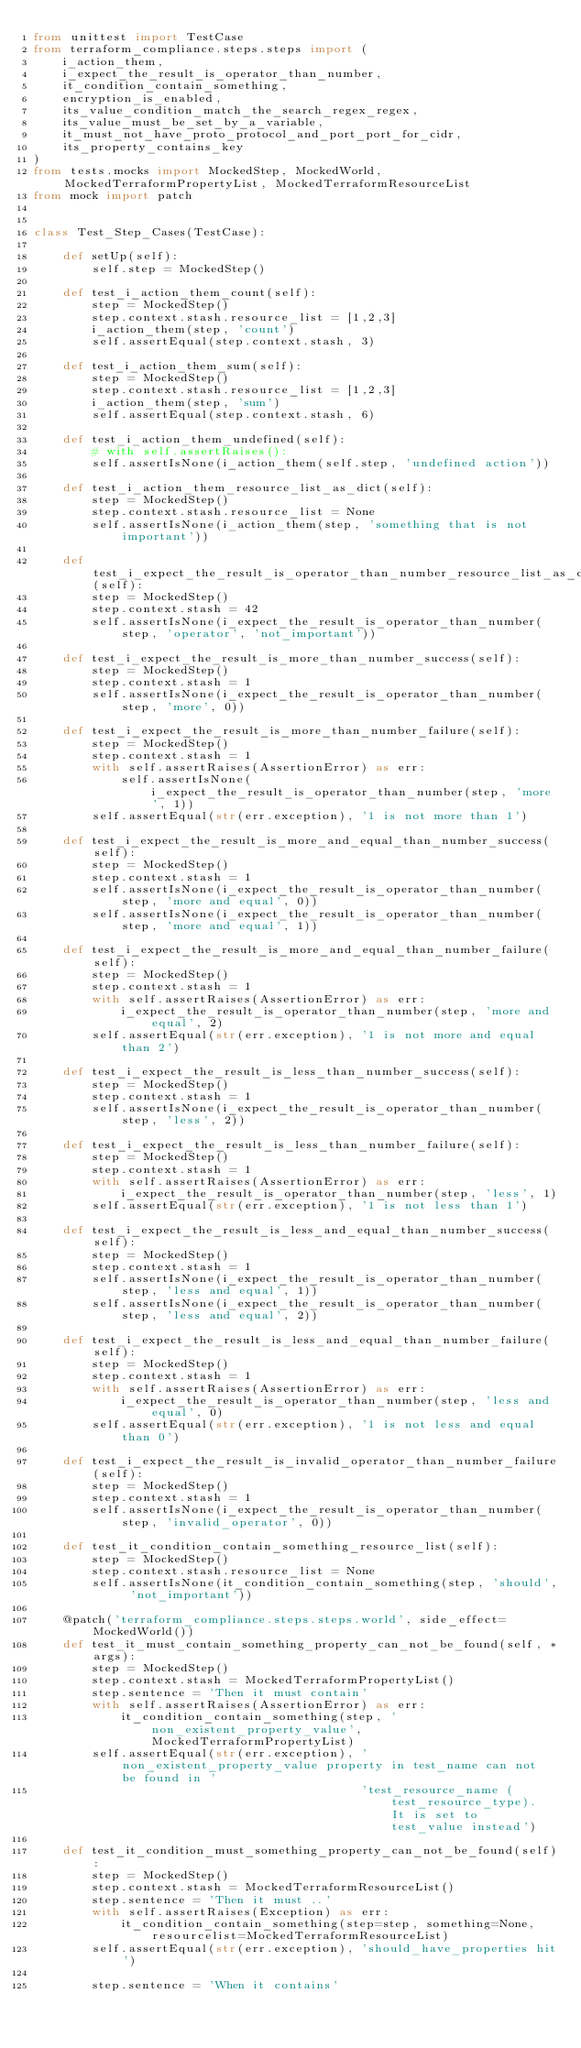Convert code to text. <code><loc_0><loc_0><loc_500><loc_500><_Python_>from unittest import TestCase
from terraform_compliance.steps.steps import (
    i_action_them,
    i_expect_the_result_is_operator_than_number,
    it_condition_contain_something,
    encryption_is_enabled,
    its_value_condition_match_the_search_regex_regex,
    its_value_must_be_set_by_a_variable,
    it_must_not_have_proto_protocol_and_port_port_for_cidr,
    its_property_contains_key
)
from tests.mocks import MockedStep, MockedWorld, MockedTerraformPropertyList, MockedTerraformResourceList
from mock import patch


class Test_Step_Cases(TestCase):

    def setUp(self):
        self.step = MockedStep()

    def test_i_action_them_count(self):
        step = MockedStep()
        step.context.stash.resource_list = [1,2,3]
        i_action_them(step, 'count')
        self.assertEqual(step.context.stash, 3)

    def test_i_action_them_sum(self):
        step = MockedStep()
        step.context.stash.resource_list = [1,2,3]
        i_action_them(step, 'sum')
        self.assertEqual(step.context.stash, 6)

    def test_i_action_them_undefined(self):
        # with self.assertRaises():
        self.assertIsNone(i_action_them(self.step, 'undefined action'))

    def test_i_action_them_resource_list_as_dict(self):
        step = MockedStep()
        step.context.stash.resource_list = None
        self.assertIsNone(i_action_them(step, 'something that is not important'))

    def test_i_expect_the_result_is_operator_than_number_resource_list_as_dict(self):
        step = MockedStep()
        step.context.stash = 42
        self.assertIsNone(i_expect_the_result_is_operator_than_number(step, 'operator', 'not_important'))

    def test_i_expect_the_result_is_more_than_number_success(self):
        step = MockedStep()
        step.context.stash = 1
        self.assertIsNone(i_expect_the_result_is_operator_than_number(step, 'more', 0))

    def test_i_expect_the_result_is_more_than_number_failure(self):
        step = MockedStep()
        step.context.stash = 1
        with self.assertRaises(AssertionError) as err:
            self.assertIsNone(i_expect_the_result_is_operator_than_number(step, 'more', 1))
        self.assertEqual(str(err.exception), '1 is not more than 1')

    def test_i_expect_the_result_is_more_and_equal_than_number_success(self):
        step = MockedStep()
        step.context.stash = 1
        self.assertIsNone(i_expect_the_result_is_operator_than_number(step, 'more and equal', 0))
        self.assertIsNone(i_expect_the_result_is_operator_than_number(step, 'more and equal', 1))

    def test_i_expect_the_result_is_more_and_equal_than_number_failure(self):
        step = MockedStep()
        step.context.stash = 1
        with self.assertRaises(AssertionError) as err:
            i_expect_the_result_is_operator_than_number(step, 'more and equal', 2)
        self.assertEqual(str(err.exception), '1 is not more and equal than 2')

    def test_i_expect_the_result_is_less_than_number_success(self):
        step = MockedStep()
        step.context.stash = 1
        self.assertIsNone(i_expect_the_result_is_operator_than_number(step, 'less', 2))

    def test_i_expect_the_result_is_less_than_number_failure(self):
        step = MockedStep()
        step.context.stash = 1
        with self.assertRaises(AssertionError) as err:
            i_expect_the_result_is_operator_than_number(step, 'less', 1)
        self.assertEqual(str(err.exception), '1 is not less than 1')

    def test_i_expect_the_result_is_less_and_equal_than_number_success(self):
        step = MockedStep()
        step.context.stash = 1
        self.assertIsNone(i_expect_the_result_is_operator_than_number(step, 'less and equal', 1))
        self.assertIsNone(i_expect_the_result_is_operator_than_number(step, 'less and equal', 2))

    def test_i_expect_the_result_is_less_and_equal_than_number_failure(self):
        step = MockedStep()
        step.context.stash = 1
        with self.assertRaises(AssertionError) as err:
            i_expect_the_result_is_operator_than_number(step, 'less and equal', 0)
        self.assertEqual(str(err.exception), '1 is not less and equal than 0')

    def test_i_expect_the_result_is_invalid_operator_than_number_failure(self):
        step = MockedStep()
        step.context.stash = 1
        self.assertIsNone(i_expect_the_result_is_operator_than_number(step, 'invalid_operator', 0))

    def test_it_condition_contain_something_resource_list(self):
        step = MockedStep()
        step.context.stash.resource_list = None
        self.assertIsNone(it_condition_contain_something(step, 'should', 'not_important'))

    @patch('terraform_compliance.steps.steps.world', side_effect=MockedWorld())
    def test_it_must_contain_something_property_can_not_be_found(self, *args):
        step = MockedStep()
        step.context.stash = MockedTerraformPropertyList()
        step.sentence = 'Then it must contain'
        with self.assertRaises(AssertionError) as err:
            it_condition_contain_something(step, 'non_existent_property_value', MockedTerraformPropertyList)
        self.assertEqual(str(err.exception), 'non_existent_property_value property in test_name can not be found in ' 
                                             'test_resource_name (test_resource_type). It is set to test_value instead')

    def test_it_condition_must_something_property_can_not_be_found(self):
        step = MockedStep()
        step.context.stash = MockedTerraformResourceList()
        step.sentence = 'Then it must ..'
        with self.assertRaises(Exception) as err:
            it_condition_contain_something(step=step, something=None, resourcelist=MockedTerraformResourceList)
        self.assertEqual(str(err.exception), 'should_have_properties hit')

        step.sentence = 'When it contains'</code> 